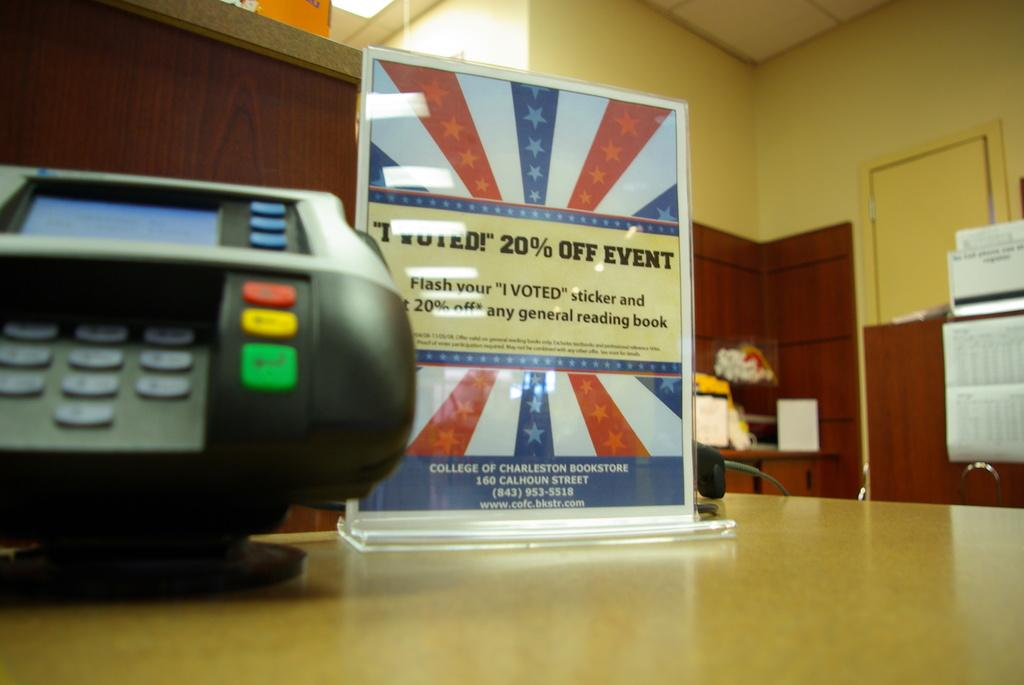What type of electronic device is visible in the image? The image contains an electronic device, but the specific type is not mentioned in the facts. What is placed on the table in the image? There is a poster on a table in the image. What can be seen behind the table in the image? There is a flower bouquet behind the table in the image. What type of written information is present in the image? There are notices in the image. How many zippers are visible on the electronic device in the image? There is no mention of zippers on the electronic device in the image, as the facts do not provide any information about its design or features. What type of territory is depicted in the image? The image does not depict any territory; it contains an electronic device, a poster, a flower bouquet, and notices. 